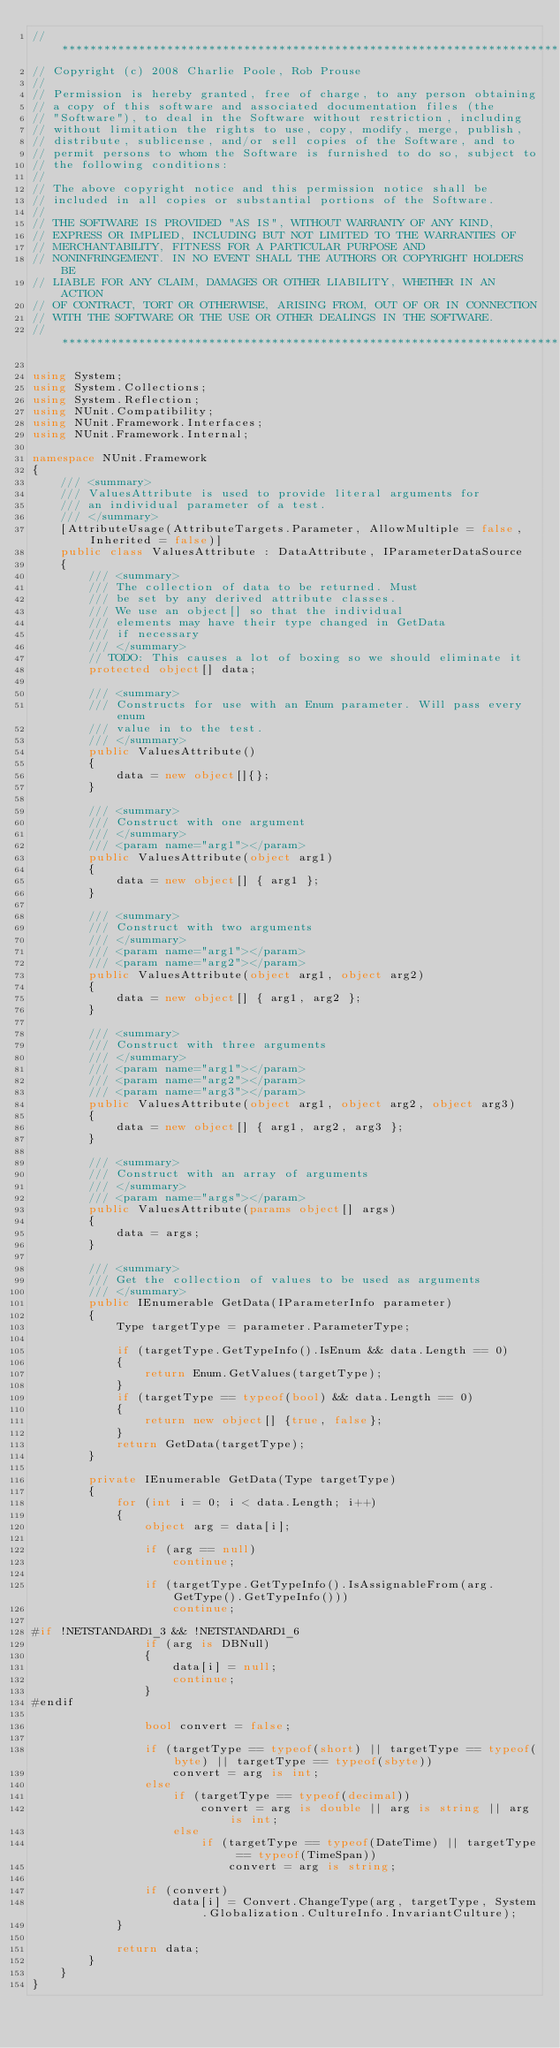Convert code to text. <code><loc_0><loc_0><loc_500><loc_500><_C#_>// ***********************************************************************
// Copyright (c) 2008 Charlie Poole, Rob Prouse
//
// Permission is hereby granted, free of charge, to any person obtaining
// a copy of this software and associated documentation files (the
// "Software"), to deal in the Software without restriction, including
// without limitation the rights to use, copy, modify, merge, publish,
// distribute, sublicense, and/or sell copies of the Software, and to
// permit persons to whom the Software is furnished to do so, subject to
// the following conditions:
// 
// The above copyright notice and this permission notice shall be
// included in all copies or substantial portions of the Software.
// 
// THE SOFTWARE IS PROVIDED "AS IS", WITHOUT WARRANTY OF ANY KIND,
// EXPRESS OR IMPLIED, INCLUDING BUT NOT LIMITED TO THE WARRANTIES OF
// MERCHANTABILITY, FITNESS FOR A PARTICULAR PURPOSE AND
// NONINFRINGEMENT. IN NO EVENT SHALL THE AUTHORS OR COPYRIGHT HOLDERS BE
// LIABLE FOR ANY CLAIM, DAMAGES OR OTHER LIABILITY, WHETHER IN AN ACTION
// OF CONTRACT, TORT OR OTHERWISE, ARISING FROM, OUT OF OR IN CONNECTION
// WITH THE SOFTWARE OR THE USE OR OTHER DEALINGS IN THE SOFTWARE.
// ***********************************************************************

using System;
using System.Collections;
using System.Reflection;
using NUnit.Compatibility;
using NUnit.Framework.Interfaces;
using NUnit.Framework.Internal;

namespace NUnit.Framework
{
    /// <summary>
    /// ValuesAttribute is used to provide literal arguments for
    /// an individual parameter of a test.
    /// </summary>
    [AttributeUsage(AttributeTargets.Parameter, AllowMultiple = false, Inherited = false)]
    public class ValuesAttribute : DataAttribute, IParameterDataSource
    {
        /// <summary>
        /// The collection of data to be returned. Must
        /// be set by any derived attribute classes.
        /// We use an object[] so that the individual
        /// elements may have their type changed in GetData
        /// if necessary
        /// </summary>
        // TODO: This causes a lot of boxing so we should eliminate it
        protected object[] data;

        /// <summary>
        /// Constructs for use with an Enum parameter. Will pass every enum
        /// value in to the test.
        /// </summary>
        public ValuesAttribute()
        {
            data = new object[]{};
        }

        /// <summary>
        /// Construct with one argument
        /// </summary>
        /// <param name="arg1"></param>
        public ValuesAttribute(object arg1)
        {
            data = new object[] { arg1 };
        }

        /// <summary>
        /// Construct with two arguments
        /// </summary>
        /// <param name="arg1"></param>
        /// <param name="arg2"></param>
        public ValuesAttribute(object arg1, object arg2)
        {
            data = new object[] { arg1, arg2 };
        }

        /// <summary>
        /// Construct with three arguments
        /// </summary>
        /// <param name="arg1"></param>
        /// <param name="arg2"></param>
        /// <param name="arg3"></param>
        public ValuesAttribute(object arg1, object arg2, object arg3)
        {
            data = new object[] { arg1, arg2, arg3 };
        }

        /// <summary>
        /// Construct with an array of arguments
        /// </summary>
        /// <param name="args"></param>
        public ValuesAttribute(params object[] args)
        {
            data = args;
        }

        /// <summary>
        /// Get the collection of values to be used as arguments
        /// </summary>
        public IEnumerable GetData(IParameterInfo parameter)
        {
            Type targetType = parameter.ParameterType;

            if (targetType.GetTypeInfo().IsEnum && data.Length == 0)
            {
                return Enum.GetValues(targetType);
            }
            if (targetType == typeof(bool) && data.Length == 0)
            {
                return new object[] {true, false};
            }
            return GetData(targetType);
        }

        private IEnumerable GetData(Type targetType)
        {
            for (int i = 0; i < data.Length; i++)
            {
                object arg = data[i];

                if (arg == null)
                    continue;

                if (targetType.GetTypeInfo().IsAssignableFrom(arg.GetType().GetTypeInfo()))
                    continue;

#if !NETSTANDARD1_3 && !NETSTANDARD1_6
                if (arg is DBNull)
                {
                    data[i] = null;
                    continue;
                }
#endif

                bool convert = false;

                if (targetType == typeof(short) || targetType == typeof(byte) || targetType == typeof(sbyte))
                    convert = arg is int;
                else
                    if (targetType == typeof(decimal))
                        convert = arg is double || arg is string || arg is int;
                    else
                        if (targetType == typeof(DateTime) || targetType == typeof(TimeSpan))
                            convert = arg is string;

                if (convert)
                    data[i] = Convert.ChangeType(arg, targetType, System.Globalization.CultureInfo.InvariantCulture);
            }

            return data;
        }
    }
}
</code> 